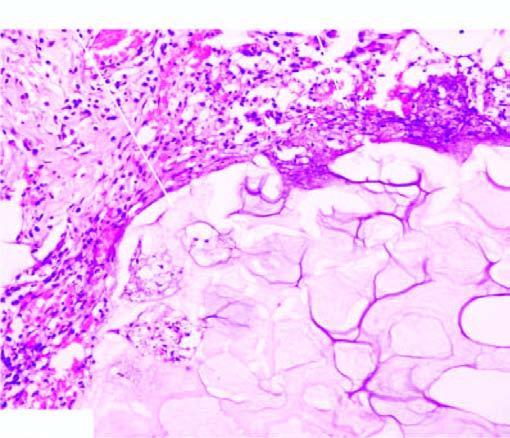s there periphery, coarse basophilic granular debris while the periphery shows a few mixed inflammatory cells?
Answer the question using a single word or phrase. No 